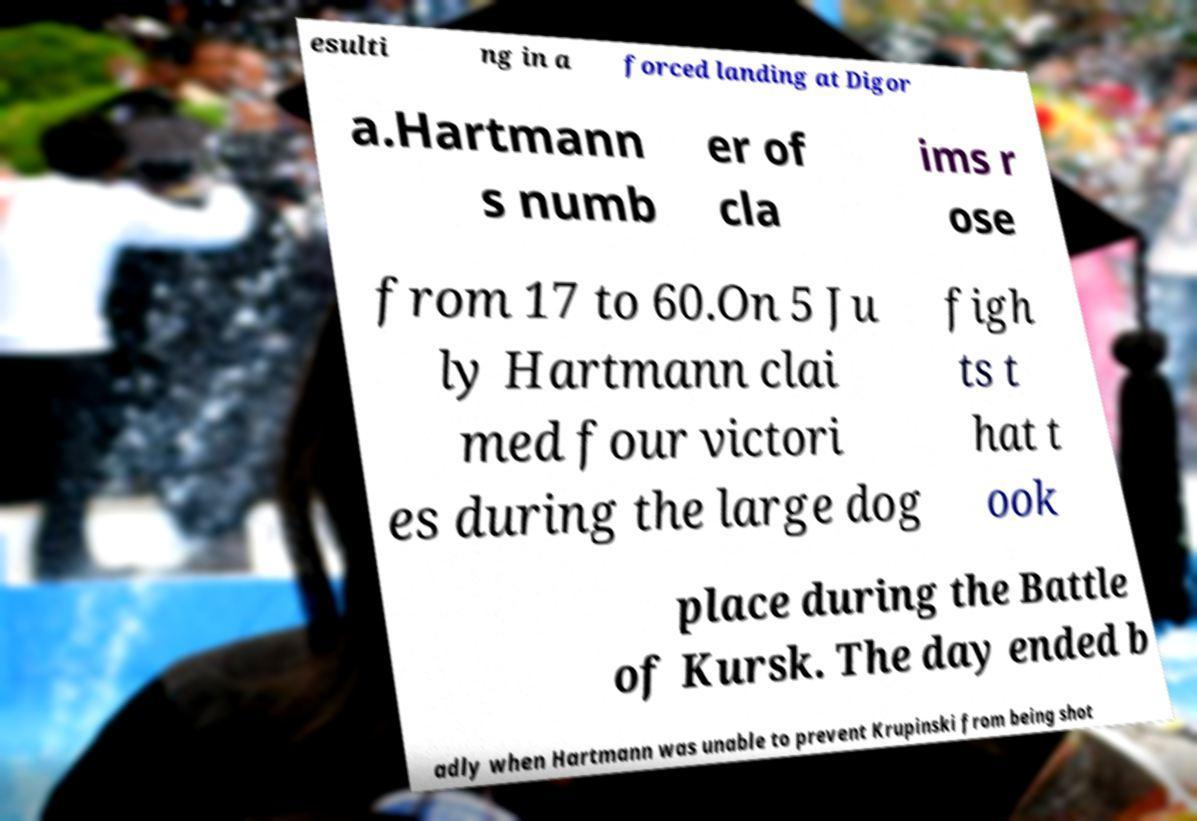Could you extract and type out the text from this image? esulti ng in a forced landing at Digor a.Hartmann s numb er of cla ims r ose from 17 to 60.On 5 Ju ly Hartmann clai med four victori es during the large dog figh ts t hat t ook place during the Battle of Kursk. The day ended b adly when Hartmann was unable to prevent Krupinski from being shot 